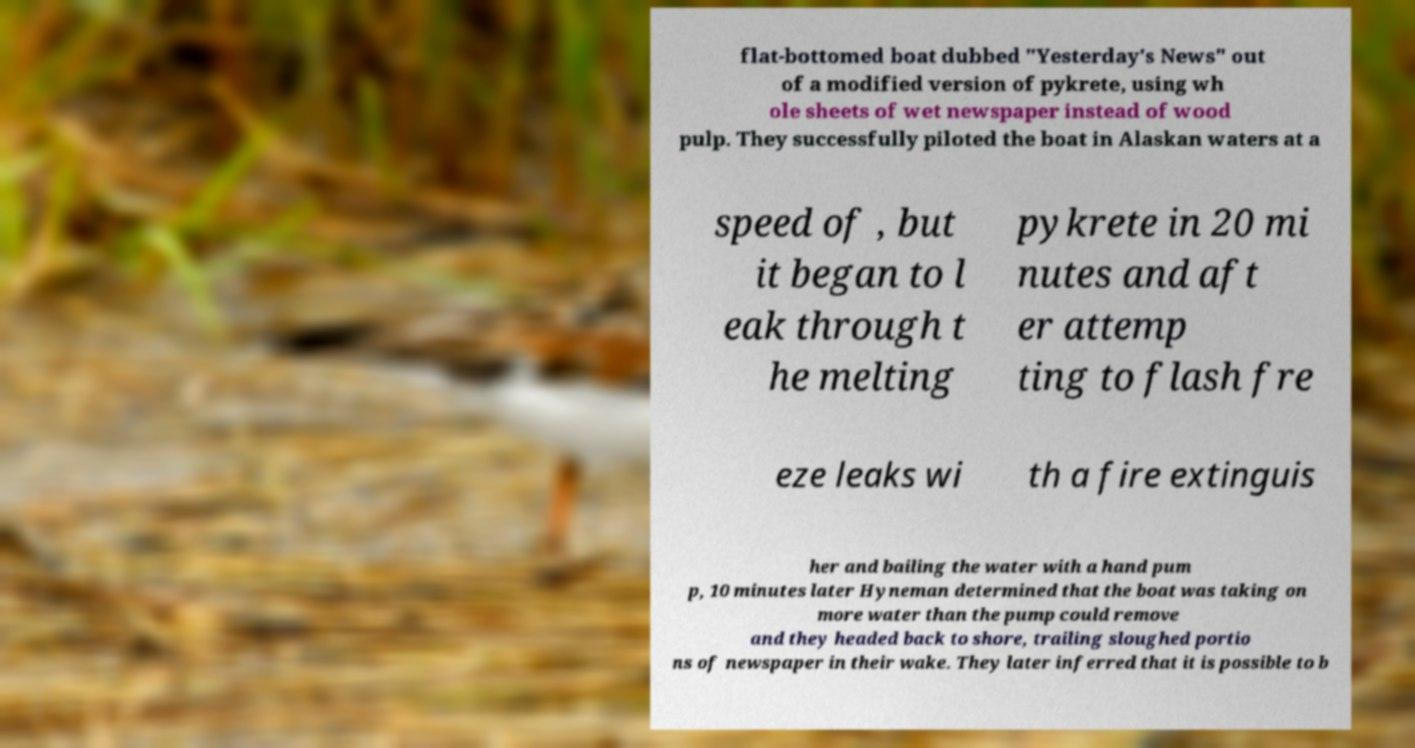Can you read and provide the text displayed in the image?This photo seems to have some interesting text. Can you extract and type it out for me? flat-bottomed boat dubbed "Yesterday's News" out of a modified version of pykrete, using wh ole sheets of wet newspaper instead of wood pulp. They successfully piloted the boat in Alaskan waters at a speed of , but it began to l eak through t he melting pykrete in 20 mi nutes and aft er attemp ting to flash fre eze leaks wi th a fire extinguis her and bailing the water with a hand pum p, 10 minutes later Hyneman determined that the boat was taking on more water than the pump could remove and they headed back to shore, trailing sloughed portio ns of newspaper in their wake. They later inferred that it is possible to b 